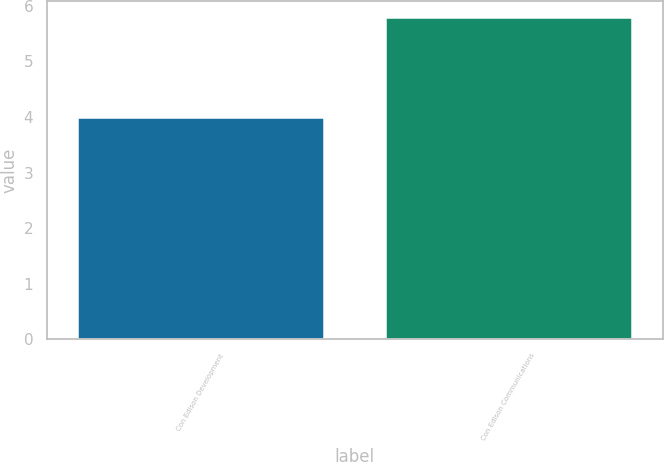<chart> <loc_0><loc_0><loc_500><loc_500><bar_chart><fcel>Con Edison Development<fcel>Con Edison Communications<nl><fcel>4<fcel>5.8<nl></chart> 